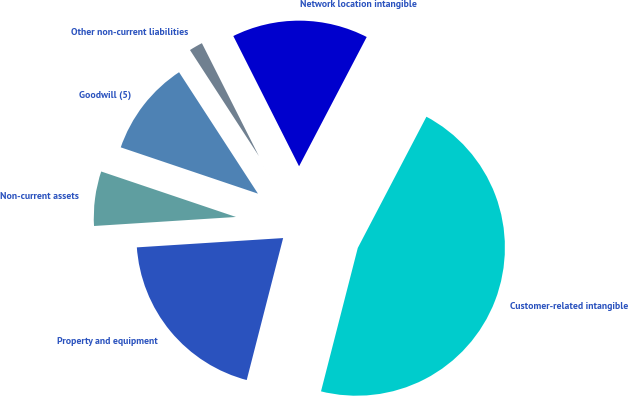<chart> <loc_0><loc_0><loc_500><loc_500><pie_chart><fcel>Non-current assets<fcel>Property and equipment<fcel>Customer-related intangible<fcel>Network location intangible<fcel>Other non-current liabilities<fcel>Goodwill (5)<nl><fcel>6.19%<fcel>19.99%<fcel>46.32%<fcel>15.11%<fcel>1.73%<fcel>10.65%<nl></chart> 